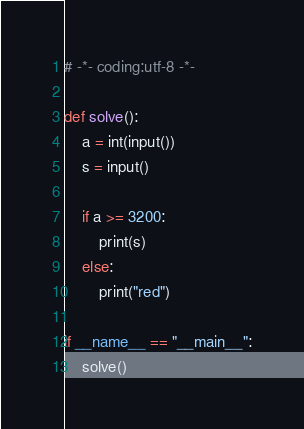<code> <loc_0><loc_0><loc_500><loc_500><_Python_># -*- coding:utf-8 -*-

def solve():
    a = int(input())
    s = input()

    if a >= 3200:
        print(s)
    else:
        print("red")

if __name__ == "__main__":
    solve()
</code> 